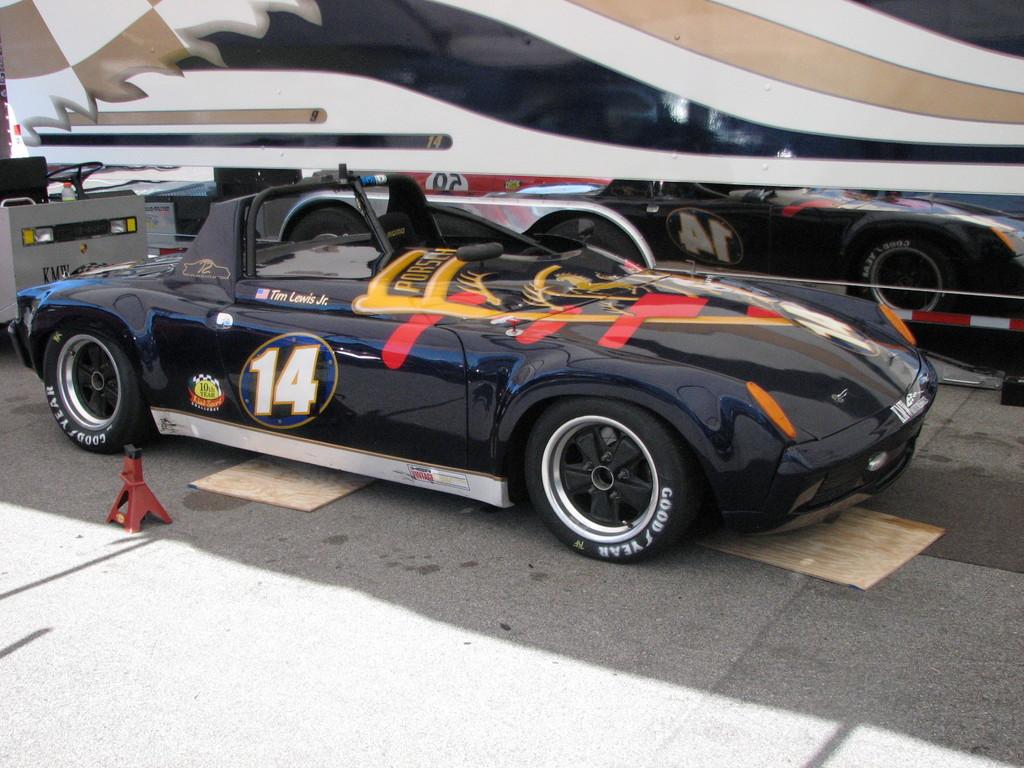What number car is this?
Provide a short and direct response. 14. What brand of tires?
Your answer should be compact. Good year. 